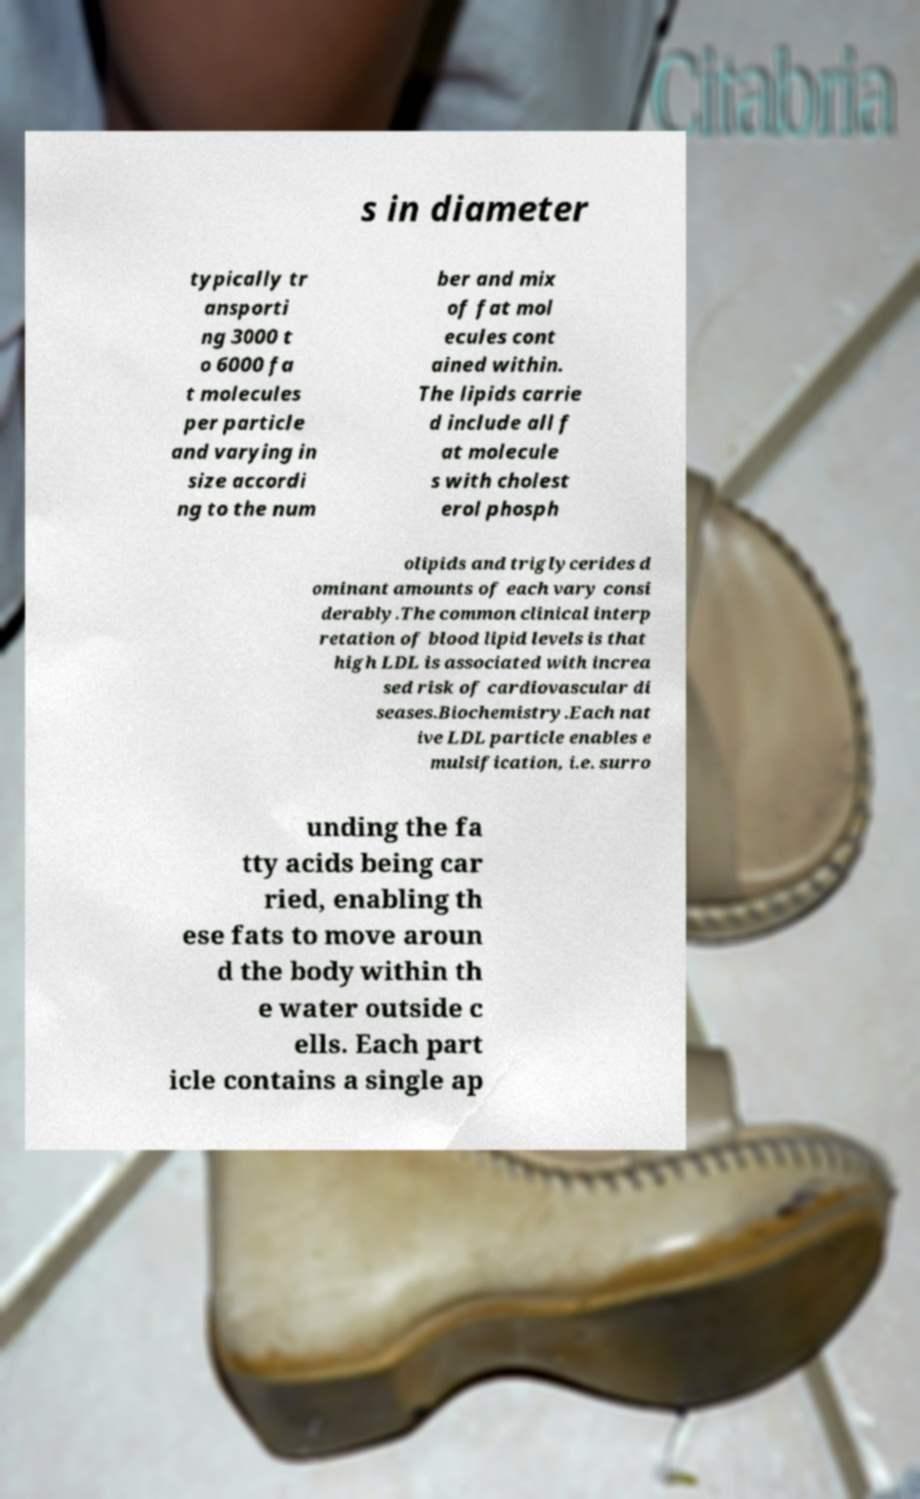Please identify and transcribe the text found in this image. s in diameter typically tr ansporti ng 3000 t o 6000 fa t molecules per particle and varying in size accordi ng to the num ber and mix of fat mol ecules cont ained within. The lipids carrie d include all f at molecule s with cholest erol phosph olipids and triglycerides d ominant amounts of each vary consi derably.The common clinical interp retation of blood lipid levels is that high LDL is associated with increa sed risk of cardiovascular di seases.Biochemistry.Each nat ive LDL particle enables e mulsification, i.e. surro unding the fa tty acids being car ried, enabling th ese fats to move aroun d the body within th e water outside c ells. Each part icle contains a single ap 